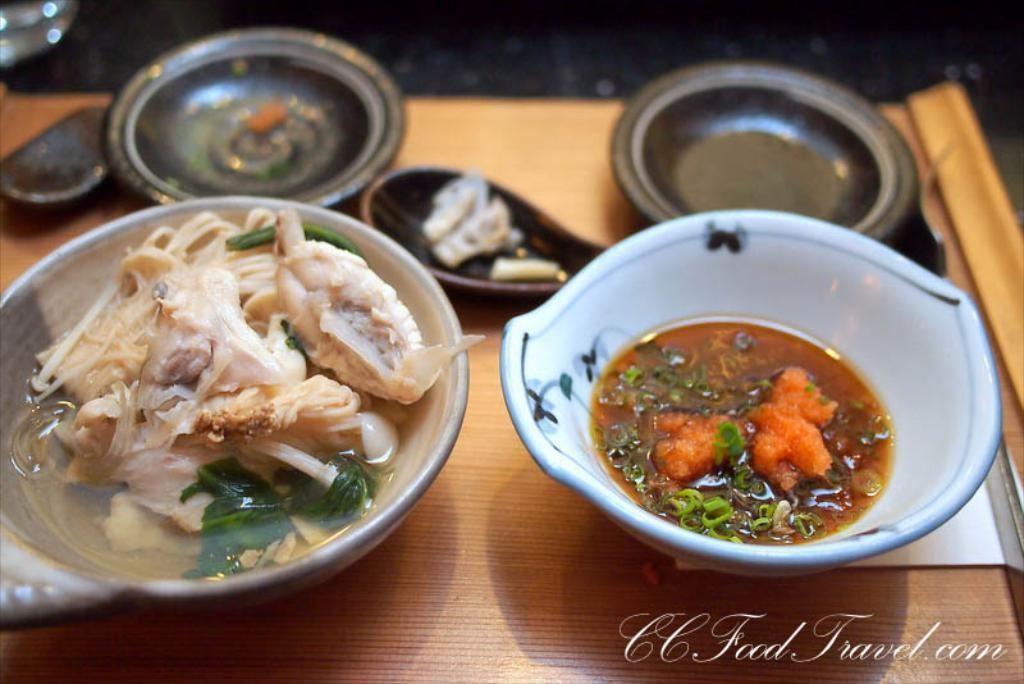What is located at the bottom of the image? There is a table at the bottom of the image. What can be found on the table? There are bowls and food on the table. What utensils are present on the table? There are spoons on the table. Can you describe the thickness of the fog in the image? There is no fog present in the image; it features a table with bowls, food, and spoons. What type of cushion is used to support the table in the image? There is no cushion mentioned or visible in the image; it only shows a table with bowls, food, and spoons. 